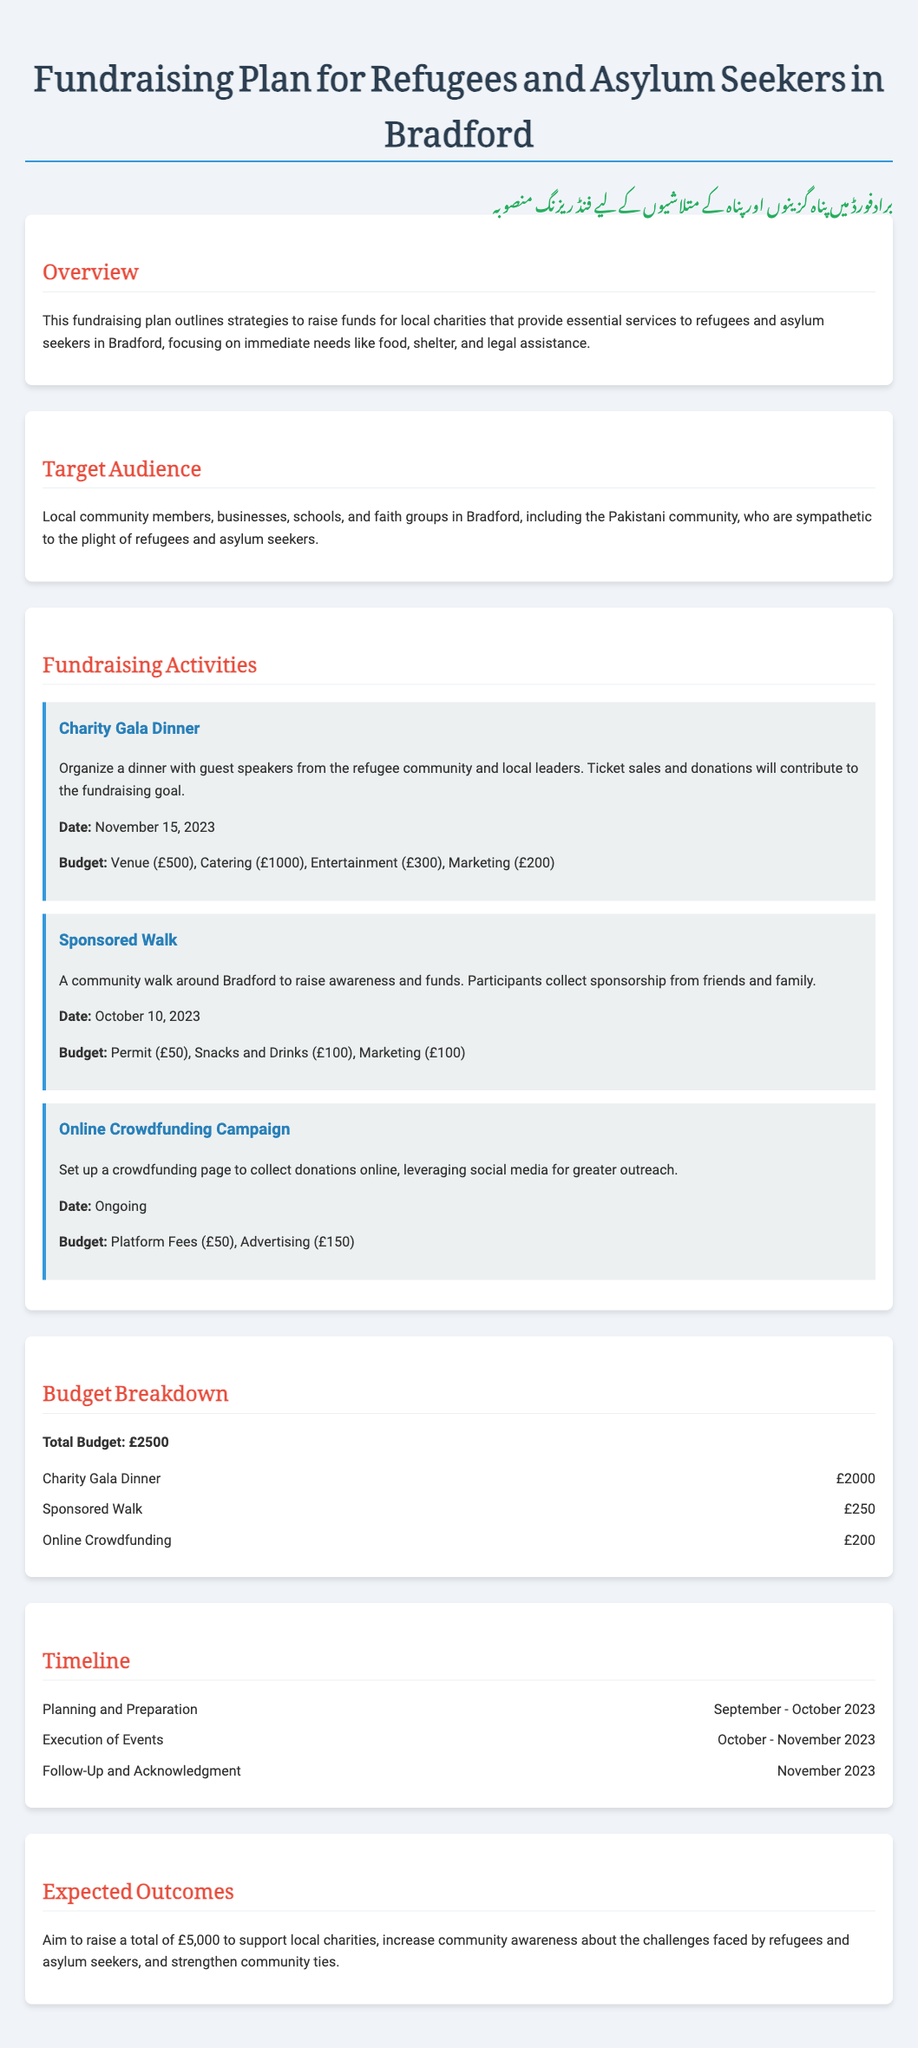What is the total budget for the fundraising plan? The total budget is explicitly stated in the document under 'Budget Breakdown'.
Answer: £2500 When is the Charity Gala Dinner scheduled? The date for the Charity Gala Dinner is clearly mentioned in the fundraising activities section.
Answer: November 15, 2023 What are the budgeted expenses for the Online Crowdfunding Campaign? The budget for the Online Crowdfunding Campaign is detailed in the 'Budget Breakdown' section.
Answer: £200 Which community is specifically mentioned as a target audience? The document identifies a specific community under the 'Target Audience' section.
Answer: Pakistani community What is the aim of the fundraising plan? The expected outcomes are summarized in the document, indicating the aim of the fundraising plan.
Answer: Raise £5,000 What is the date range for the planning and preparation phase? The timeline clearly outlines the time frame for planning and preparation.
Answer: September - October 2023 What is the main focus of the fundraising plan? The document's overview highlights the primary focus of the fundraising efforts.
Answer: Essential services for refugees and asylum seekers How many fundraising activities are listed? The number of activities can be counted in the 'Fundraising Activities' section of the document.
Answer: Three 